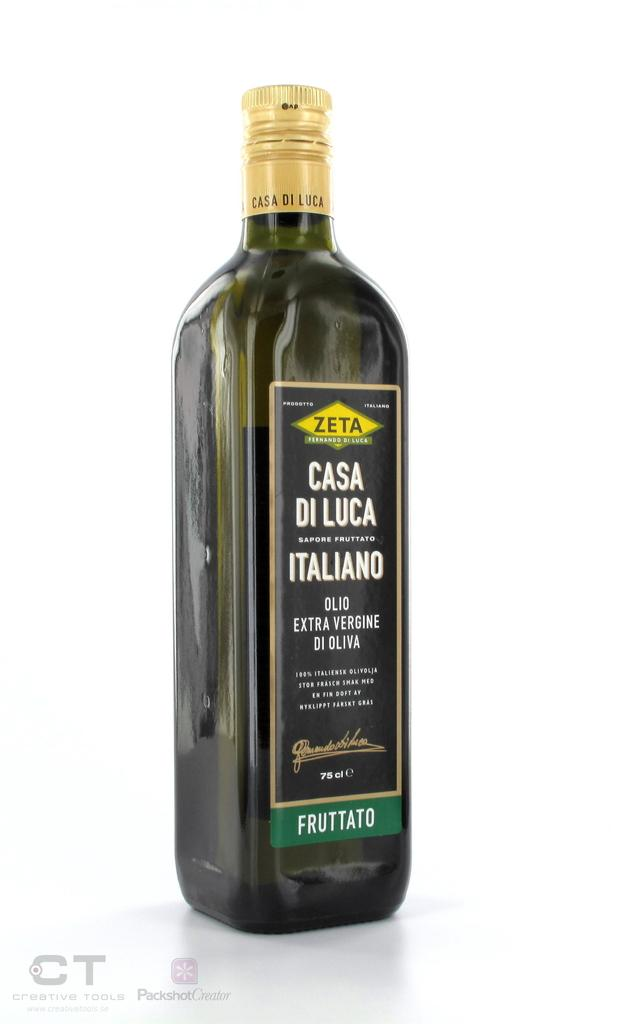<image>
Give a short and clear explanation of the subsequent image. A bottle of Zeta extra virgin olive oil. 